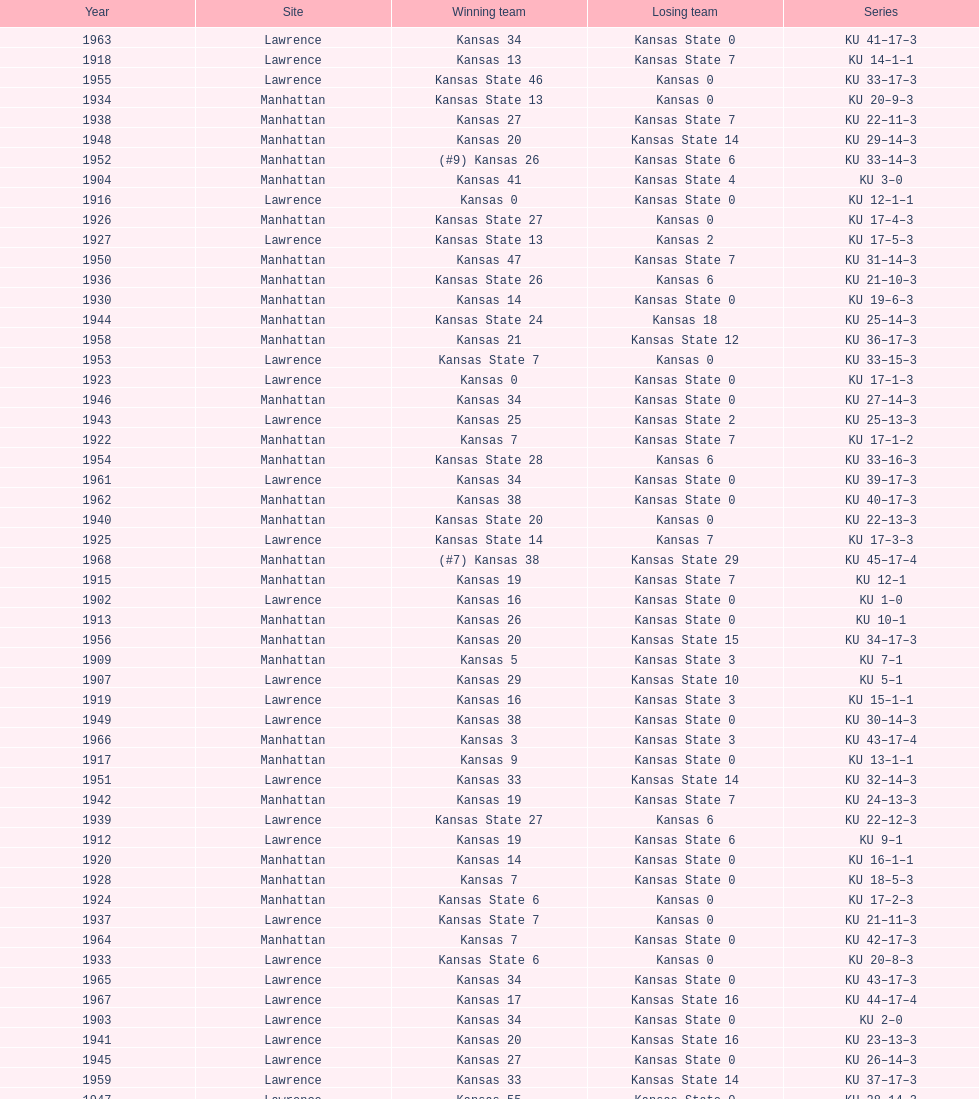How many times did kansas beat kansas state before 1910? 7. 